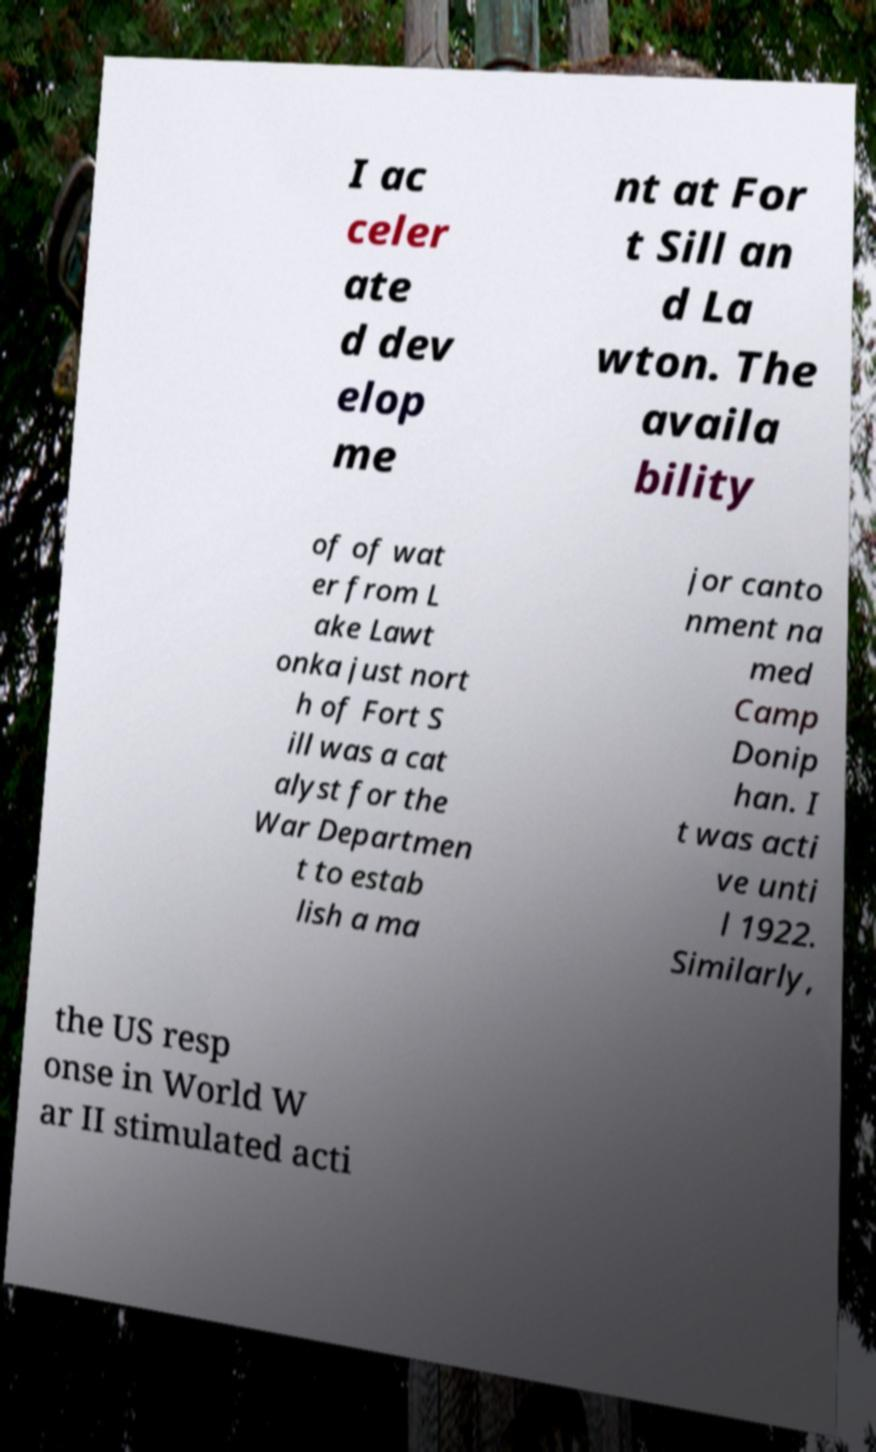Could you assist in decoding the text presented in this image and type it out clearly? I ac celer ate d dev elop me nt at For t Sill an d La wton. The availa bility of of wat er from L ake Lawt onka just nort h of Fort S ill was a cat alyst for the War Departmen t to estab lish a ma jor canto nment na med Camp Donip han. I t was acti ve unti l 1922. Similarly, the US resp onse in World W ar II stimulated acti 